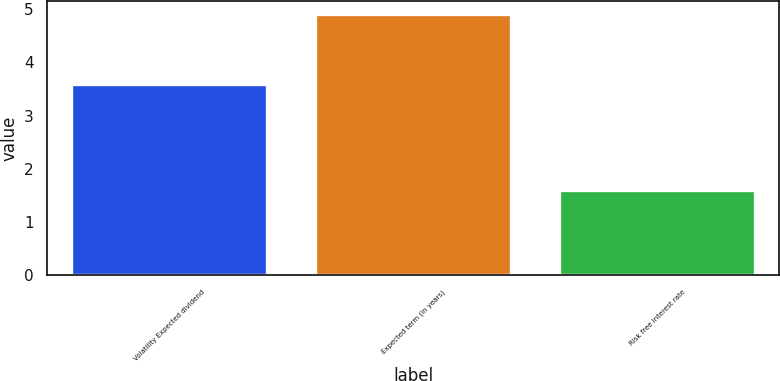Convert chart to OTSL. <chart><loc_0><loc_0><loc_500><loc_500><bar_chart><fcel>Volatility Expected dividend<fcel>Expected term (in years)<fcel>Risk free interest rate<nl><fcel>3.6<fcel>4.9<fcel>1.6<nl></chart> 